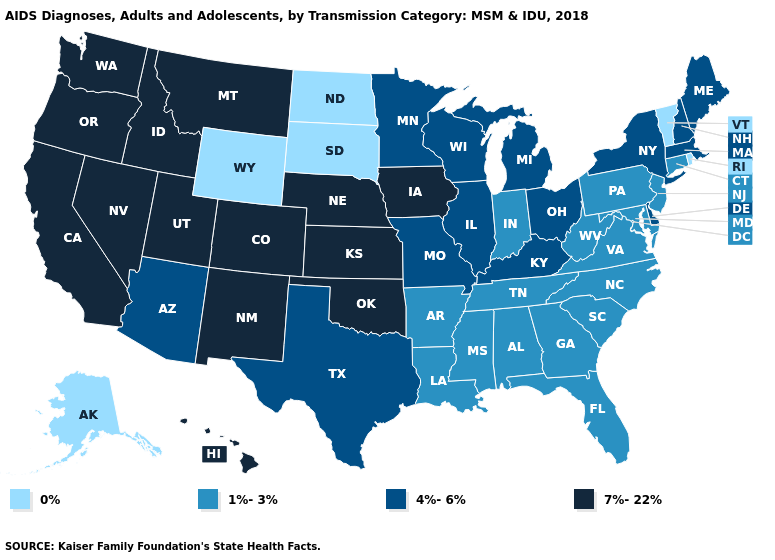Name the states that have a value in the range 0%?
Concise answer only. Alaska, North Dakota, Rhode Island, South Dakota, Vermont, Wyoming. Name the states that have a value in the range 4%-6%?
Quick response, please. Arizona, Delaware, Illinois, Kentucky, Maine, Massachusetts, Michigan, Minnesota, Missouri, New Hampshire, New York, Ohio, Texas, Wisconsin. What is the value of Florida?
Concise answer only. 1%-3%. What is the lowest value in the USA?
Write a very short answer. 0%. Does the first symbol in the legend represent the smallest category?
Keep it brief. Yes. What is the value of Alaska?
Quick response, please. 0%. What is the lowest value in the MidWest?
Concise answer only. 0%. What is the highest value in states that border Iowa?
Short answer required. 7%-22%. Name the states that have a value in the range 1%-3%?
Give a very brief answer. Alabama, Arkansas, Connecticut, Florida, Georgia, Indiana, Louisiana, Maryland, Mississippi, New Jersey, North Carolina, Pennsylvania, South Carolina, Tennessee, Virginia, West Virginia. Does South Dakota have the lowest value in the MidWest?
Give a very brief answer. Yes. What is the value of Rhode Island?
Concise answer only. 0%. How many symbols are there in the legend?
Write a very short answer. 4. Does Utah have the lowest value in the USA?
Quick response, please. No. What is the highest value in the USA?
Give a very brief answer. 7%-22%. Among the states that border Maryland , does Virginia have the highest value?
Be succinct. No. 